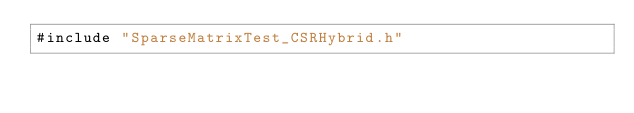Convert code to text. <code><loc_0><loc_0><loc_500><loc_500><_Cuda_>#include "SparseMatrixTest_CSRHybrid.h"
</code> 